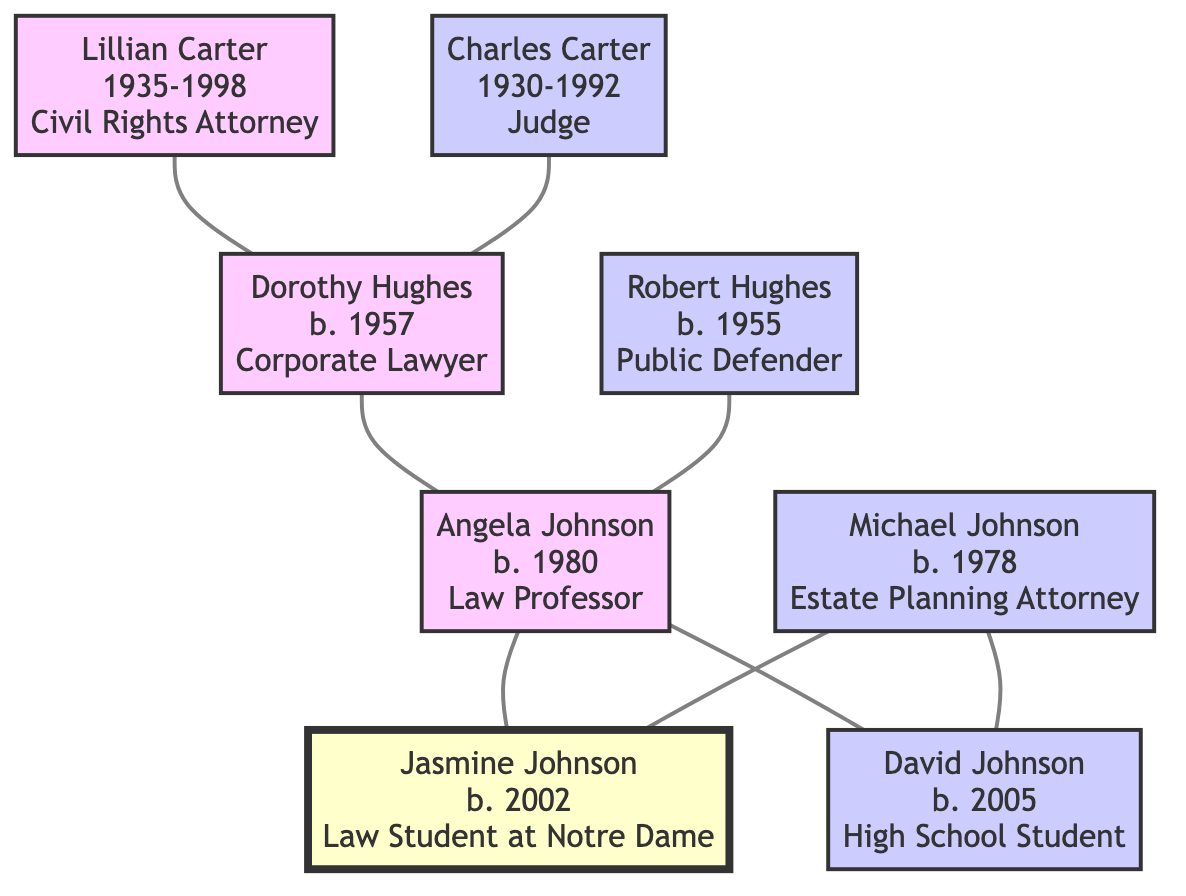What profession did Lillian Carter have? Lillian Carter is listed as a Civil Rights Attorney in the diagram.
Answer: Civil Rights Attorney How many generations are represented in the family tree? The family tree includes 4 generations: great-grandparents, grandparents, parents, and self (the student).
Answer: 4 Who is the grandfather of Jasmine Johnson? In the diagram, Robert Hughes is connected to Angela Johnson (Jasmine's mother) as her father, making him Jasmine's grandfather.
Answer: Robert Hughes What is the birth year of Dorothy Hughes? The diagram shows that Dorothy Hughes was born in 1957.
Answer: 1957 Which profession is shared by both Angela Johnson and Jasmine Johnson? Reviewing the professions listed, Angela Johnson is a Law Professor and Jasmine Johnson is a Law Student at Notre Dame, indicating a shared connection to the field of law.
Answer: Law How many lawyers are there in Jasmine Johnson's immediate family? The immediate family consists of both parents who are lawyers: Angela Johnson (Law Professor) and Michael Johnson (Estate Planning Attorney), adding up to 2 lawyers.
Answer: 2 What is the relationship of David Johnson to Jasmine Johnson? The diagram clearly indicates that David Johnson is Jasmine's brother.
Answer: Brother Which ancestor holds the highest judicial position? Among the ancestors, Charles Carter is identified as a Judge, representing the highest judicial position in the family lineage.
Answer: Judge What is the most recent birth year in the family tree? The diagram displays that Jasmine Johnson was born in 2002, which is the most recent birth year among all members in the family tree.
Answer: 2002 